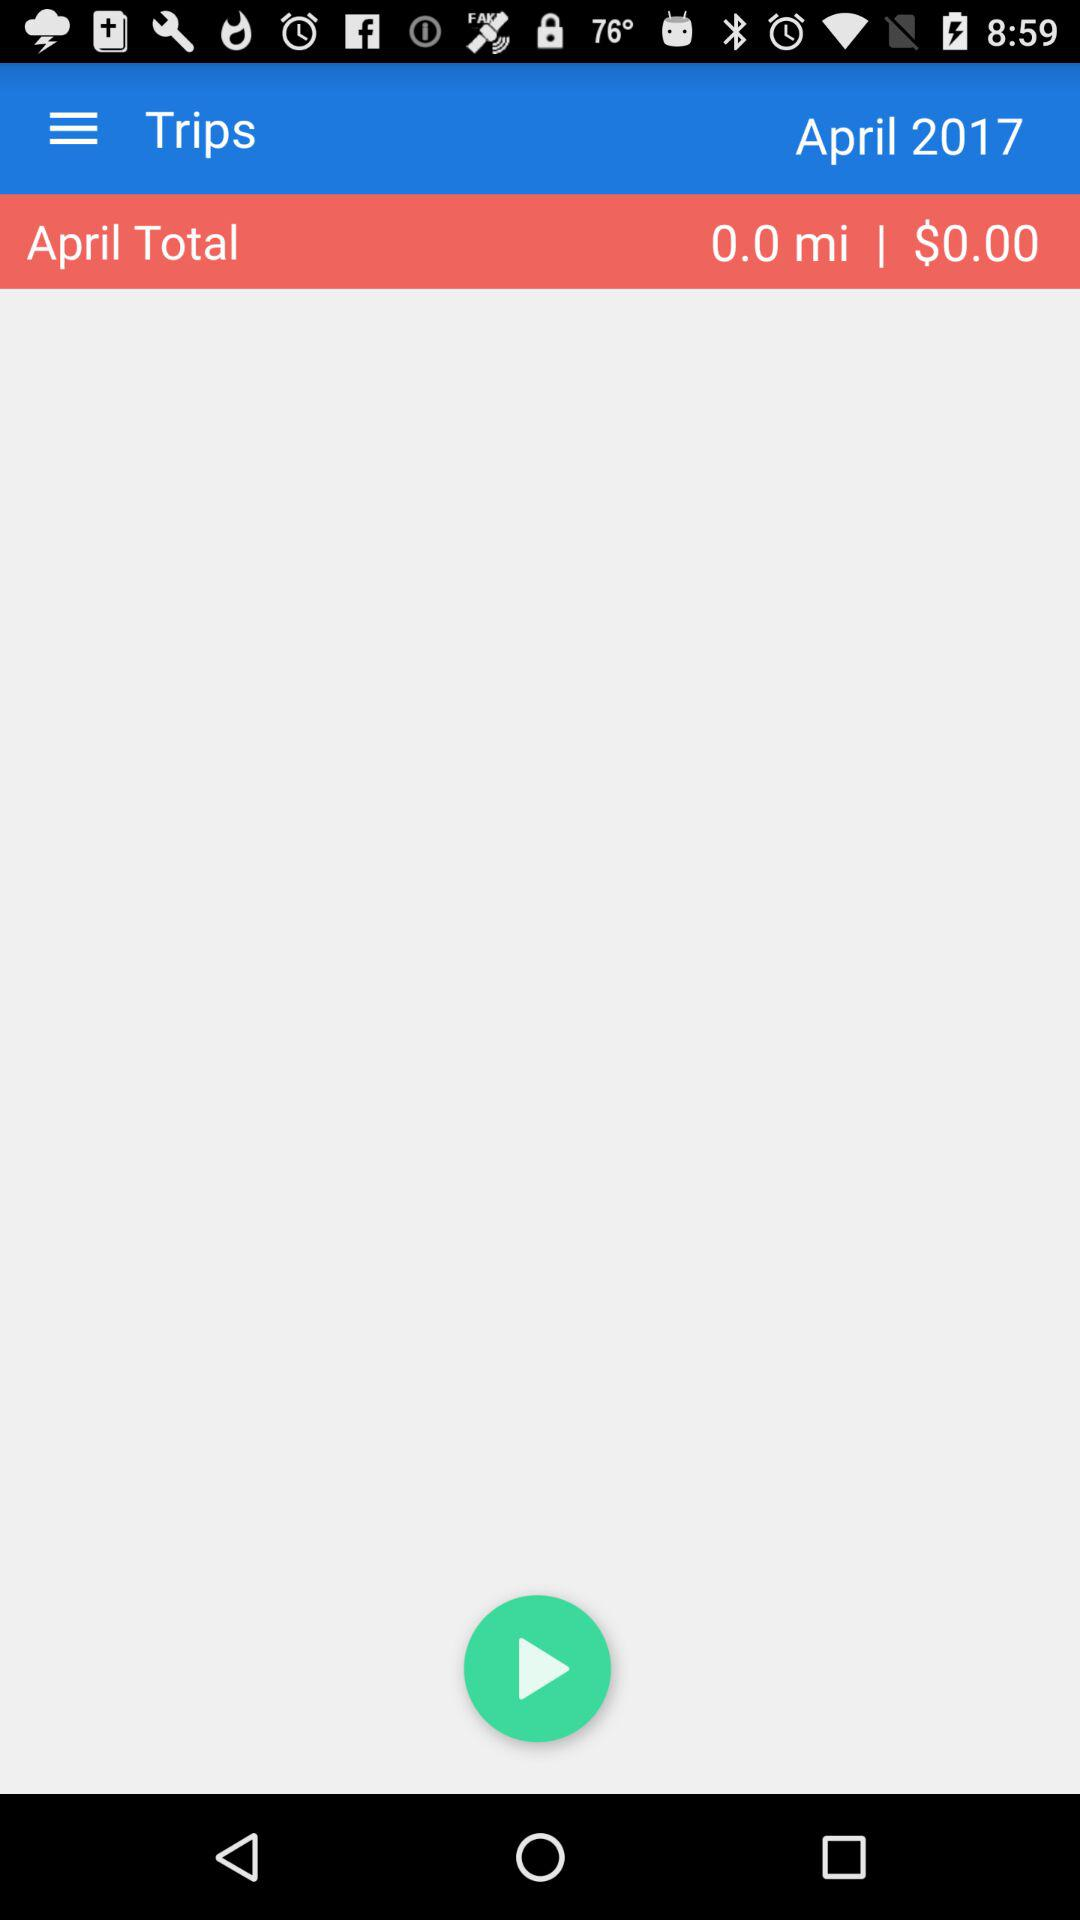What is the cost of "April Total"? The cost is $0:00. 